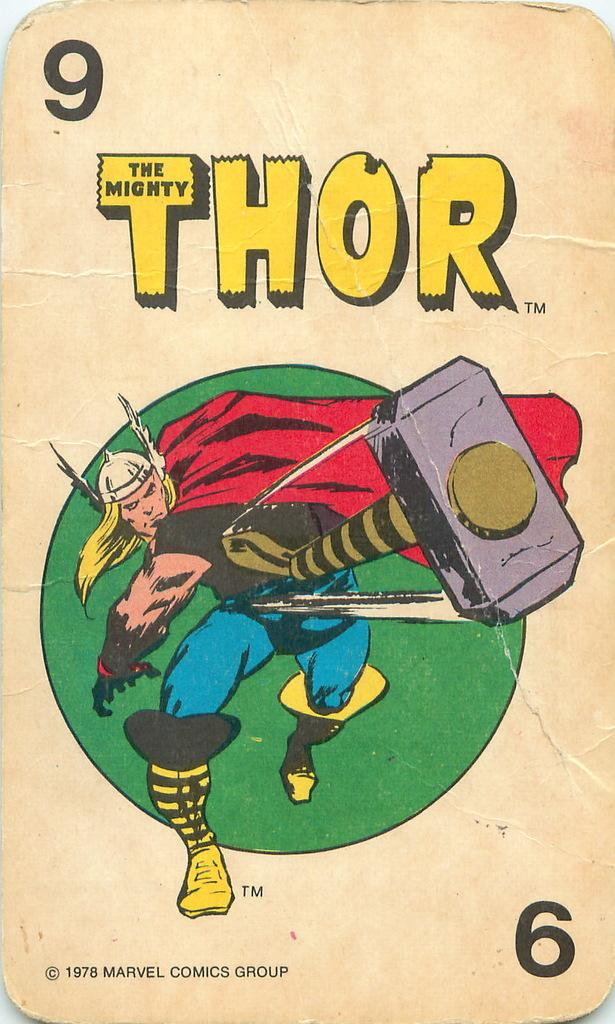What is the main object in the image? There is a playing card in the image. What number is written at the top of the card? The number "9" is written at the top of the card. What image is depicted on the card? There is an image of a cartoon character throwing a hammer on the card. What else can be seen on the card besides the number and image? There is some matter written on the card. Reasoning: Let' Let's think step by step in order to produce the conversation. We start by identifying the main subject of the image, which is the playing card. Then, we describe specific details about the card, such as the number, image, and any additional matter written on it. Each question is designed to elicit a specific detail about the image that is known from the provided facts. Absurd Question/Answer: What type of flame can be seen coming from the cartoon character's mouth on the card? There is no flame depicted on the card; it features a cartoon character throwing a hammer. 